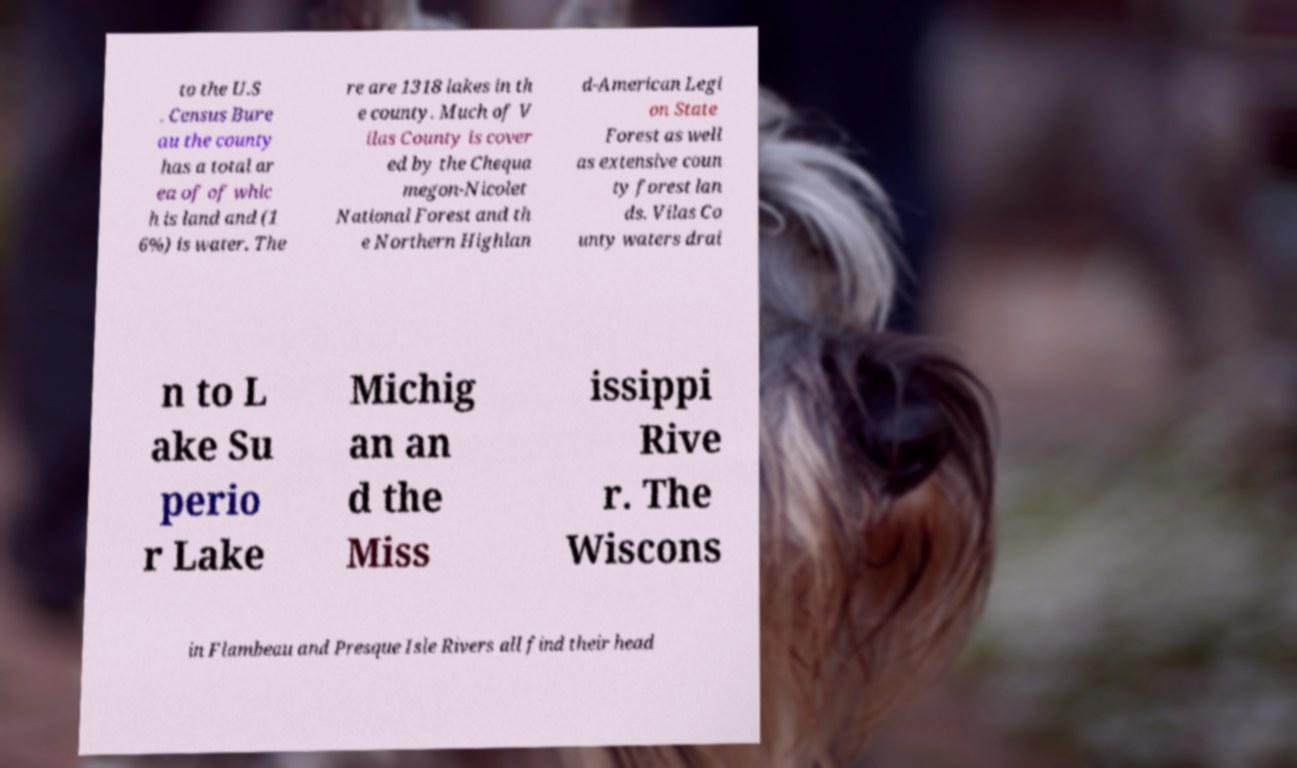For documentation purposes, I need the text within this image transcribed. Could you provide that? to the U.S . Census Bure au the county has a total ar ea of of whic h is land and (1 6%) is water. The re are 1318 lakes in th e county. Much of V ilas County is cover ed by the Chequa megon-Nicolet National Forest and th e Northern Highlan d-American Legi on State Forest as well as extensive coun ty forest lan ds. Vilas Co unty waters drai n to L ake Su perio r Lake Michig an an d the Miss issippi Rive r. The Wiscons in Flambeau and Presque Isle Rivers all find their head 